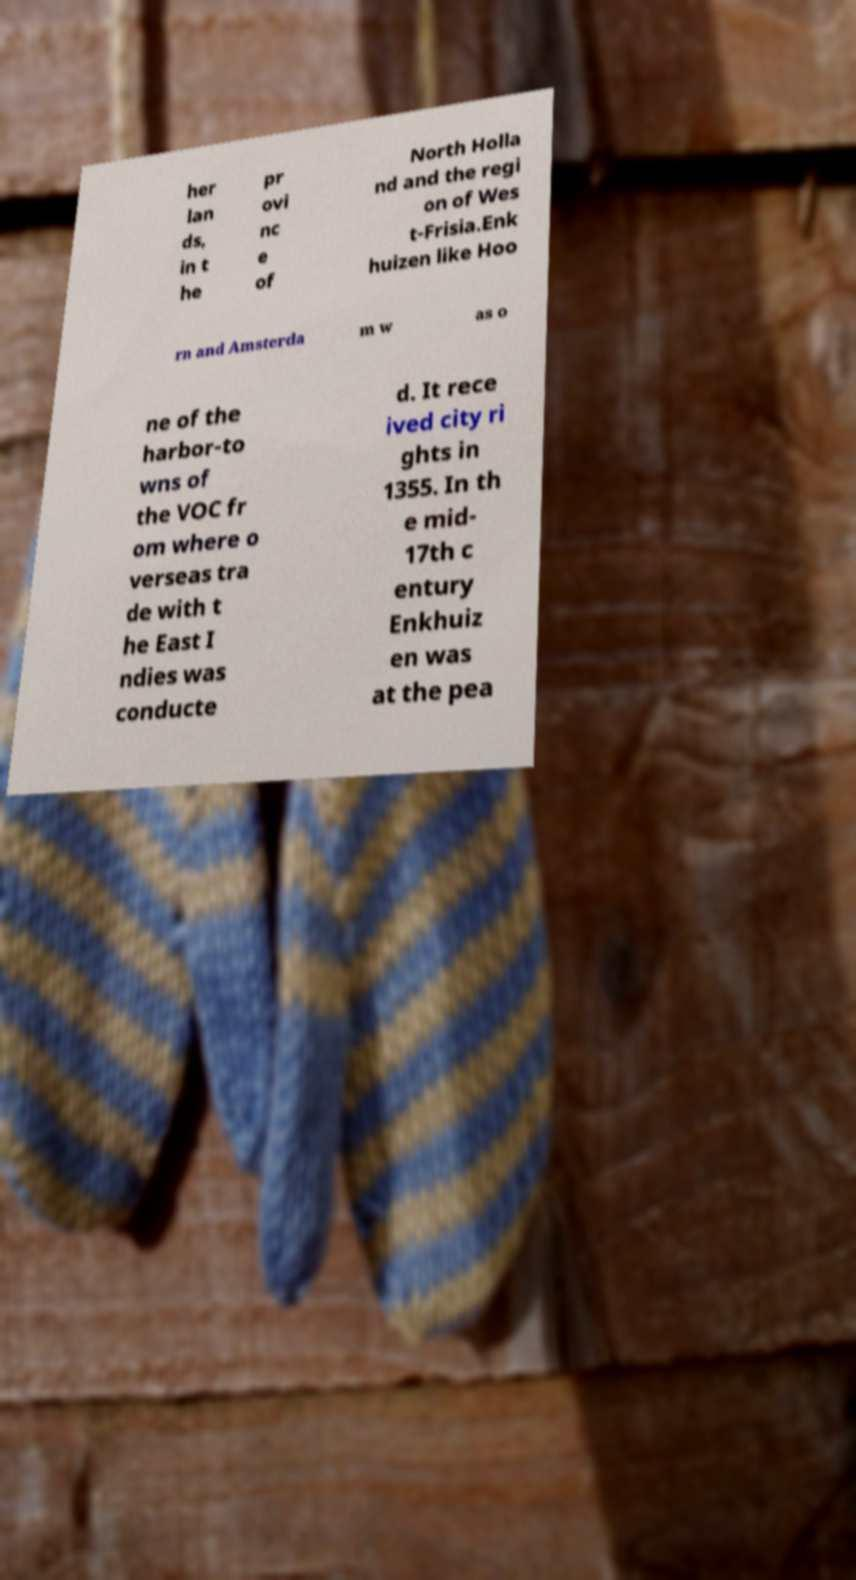Could you extract and type out the text from this image? her lan ds, in t he pr ovi nc e of North Holla nd and the regi on of Wes t-Frisia.Enk huizen like Hoo rn and Amsterda m w as o ne of the harbor-to wns of the VOC fr om where o verseas tra de with t he East I ndies was conducte d. It rece ived city ri ghts in 1355. In th e mid- 17th c entury Enkhuiz en was at the pea 